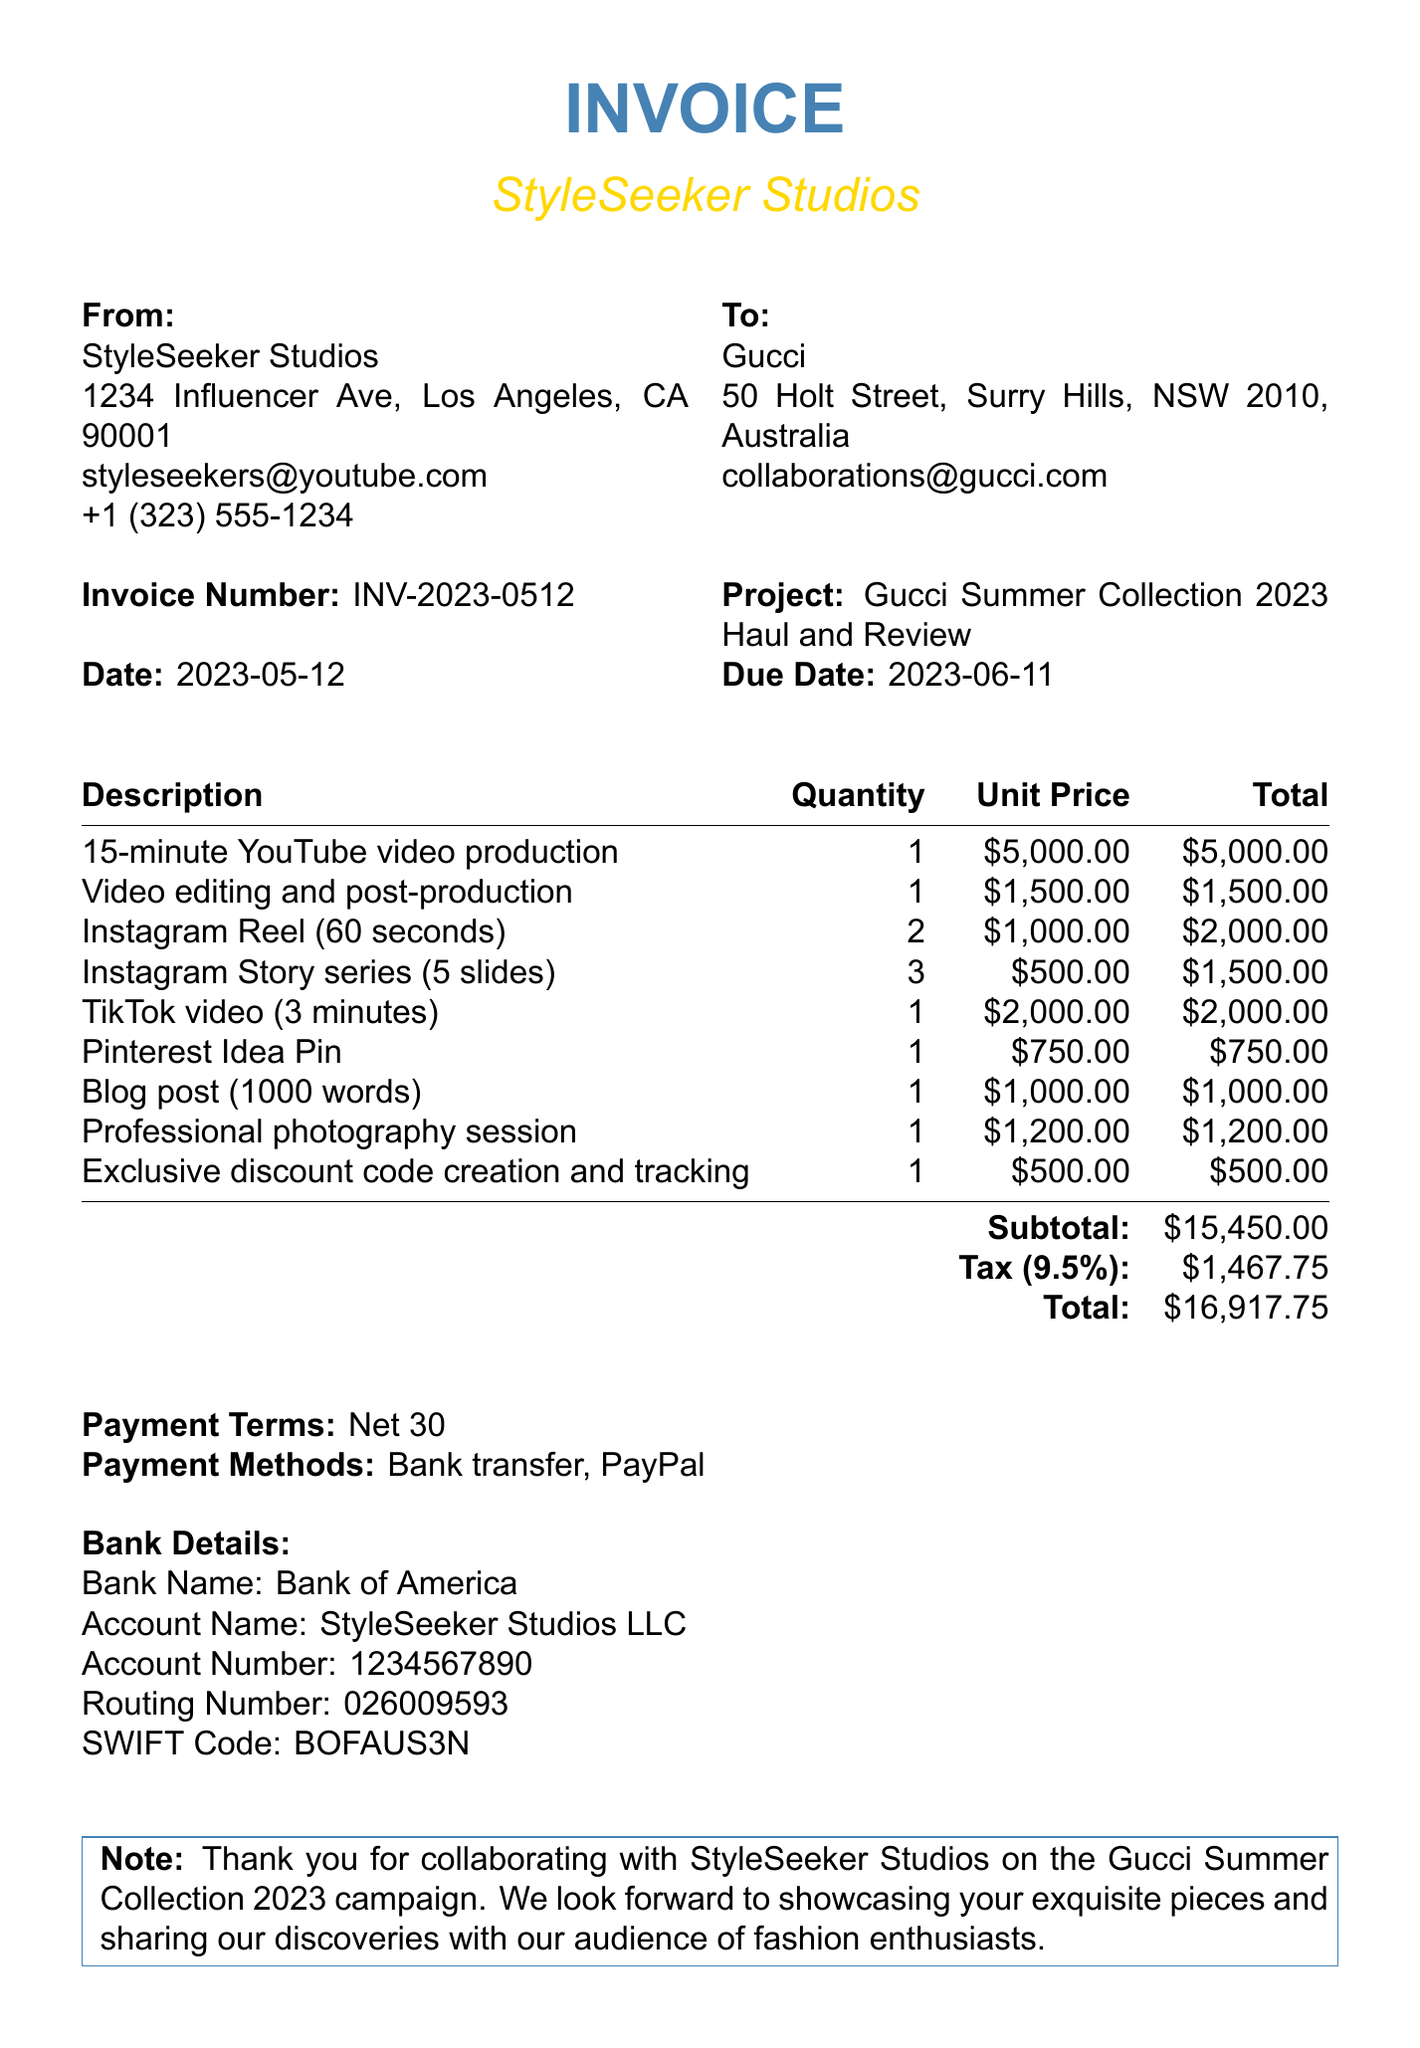What is the invoice number? The invoice number is a unique identifier for the document, which can be found in the invoice heading.
Answer: INV-2023-0512 Who is the sender of the invoice? The sender's name is listed in the "From" section of the invoice.
Answer: StyleSeeker Studios What is the subtotal amount? The subtotal is the sum of all itemized fees before tax and is listed in the invoice itemization.
Answer: $15,450.00 How many Instagram Stories are included? The quantity of Instagram Stories can be found in the itemized list of services.
Answer: 3 What is the due date for this invoice? The due date indicates when payment is expected and is provided under the invoice header.
Answer: 2023-06-11 What payment methods are accepted? The accepted payment methods are specified towards the end of the invoice.
Answer: Bank transfer, PayPal What is the tax rate applied to the invoice? The tax rate is mentioned explicitly in the tax section of the document.
Answer: 9.5% What is the total amount due? The total is the final amount including the subtotal and tax, which can be found in the invoice summary.
Answer: $16,917.75 What is the name of the bank listed for payment? The bank name can be found in the bank details section of the invoice.
Answer: Bank of America 